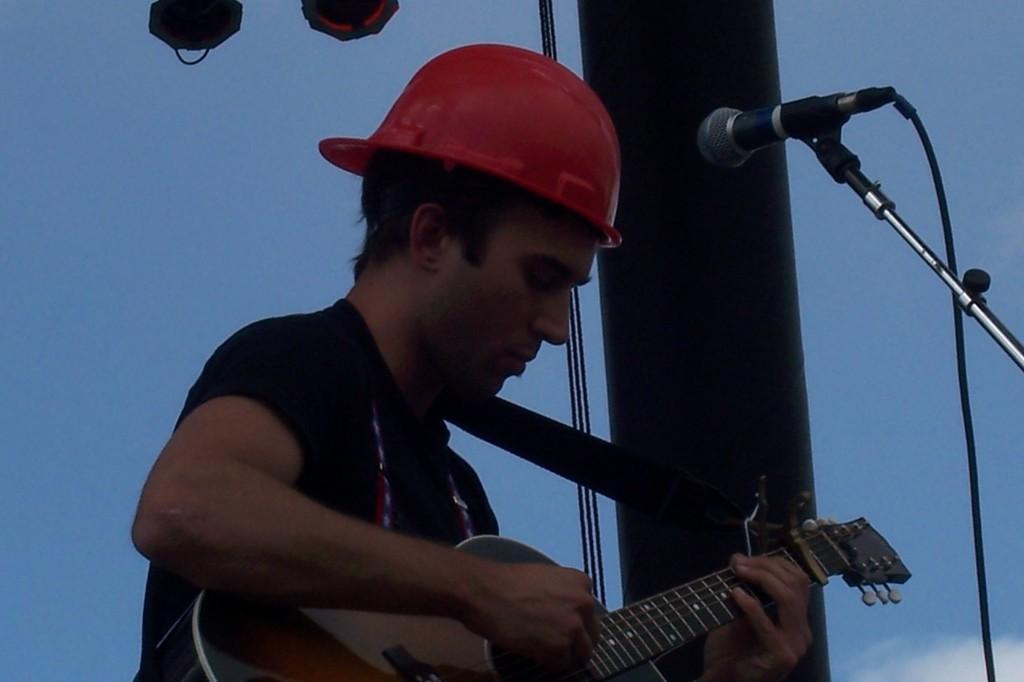Please provide a concise description of this image. In this picture there is a boy who is at the center of the image, by holding a guitar in his hands, there is a mic in front of the boy and there are spotlights above the area of the image. 